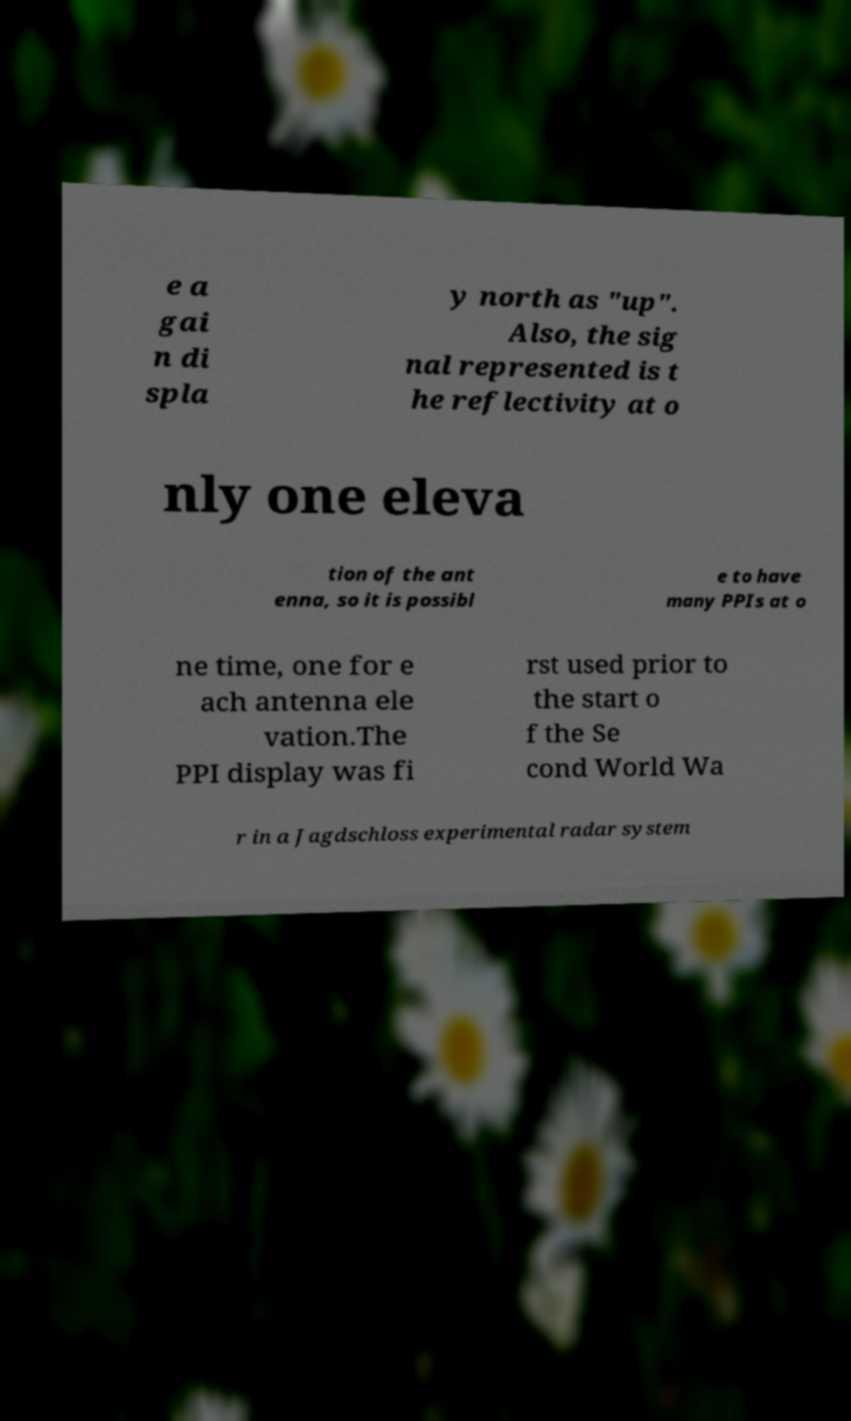Can you accurately transcribe the text from the provided image for me? e a gai n di spla y north as "up". Also, the sig nal represented is t he reflectivity at o nly one eleva tion of the ant enna, so it is possibl e to have many PPIs at o ne time, one for e ach antenna ele vation.The PPI display was fi rst used prior to the start o f the Se cond World Wa r in a Jagdschloss experimental radar system 